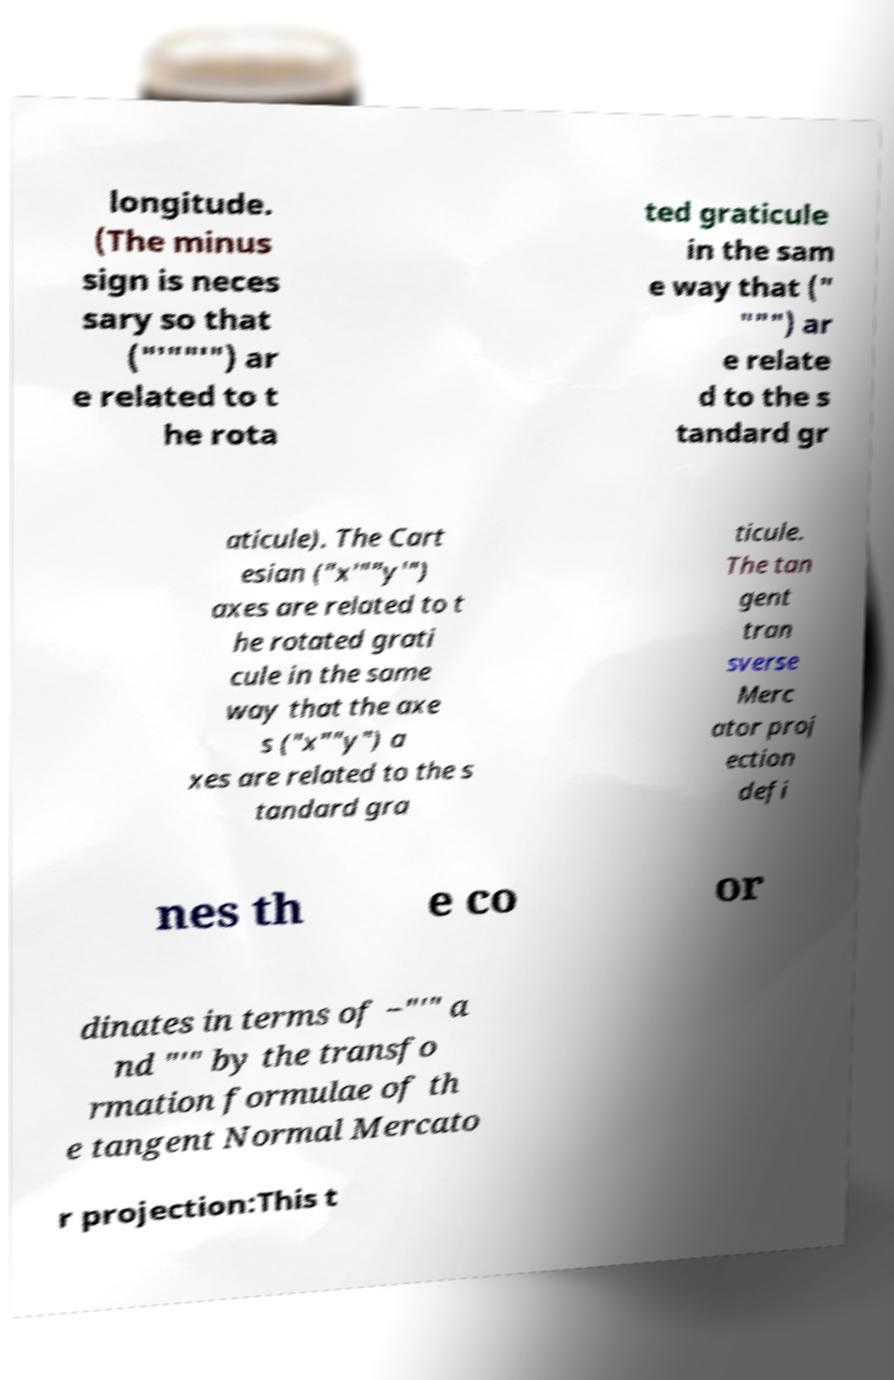I need the written content from this picture converted into text. Can you do that? longitude. (The minus sign is neces sary so that ("′""′") ar e related to t he rota ted graticule in the sam e way that (" """) ar e relate d to the s tandard gr aticule). The Cart esian ("x′""y′") axes are related to t he rotated grati cule in the same way that the axe s ("x""y") a xes are related to the s tandard gra ticule. The tan gent tran sverse Merc ator proj ection defi nes th e co or dinates in terms of −"′" a nd "′" by the transfo rmation formulae of th e tangent Normal Mercato r projection:This t 